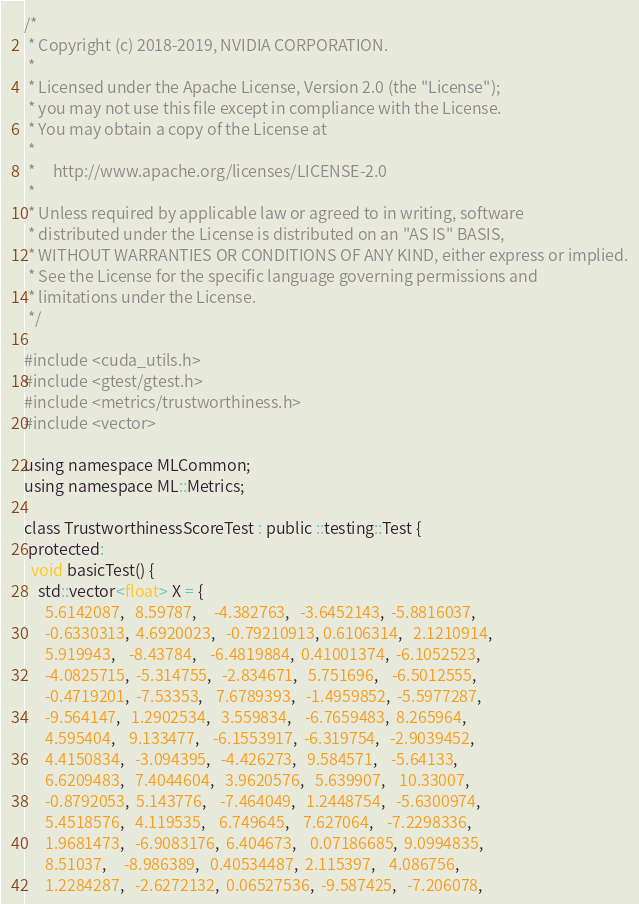<code> <loc_0><loc_0><loc_500><loc_500><_Cuda_>/*
 * Copyright (c) 2018-2019, NVIDIA CORPORATION.
 *
 * Licensed under the Apache License, Version 2.0 (the "License");
 * you may not use this file except in compliance with the License.
 * You may obtain a copy of the License at
 *
 *     http://www.apache.org/licenses/LICENSE-2.0
 *
 * Unless required by applicable law or agreed to in writing, software
 * distributed under the License is distributed on an "AS IS" BASIS,
 * WITHOUT WARRANTIES OR CONDITIONS OF ANY KIND, either express or implied.
 * See the License for the specific language governing permissions and
 * limitations under the License.
 */

#include <cuda_utils.h>
#include <gtest/gtest.h>
#include <metrics/trustworthiness.h>
#include <vector>

using namespace MLCommon;
using namespace ML::Metrics;

class TrustworthinessScoreTest : public ::testing::Test {
 protected:
  void basicTest() {
    std::vector<float> X = {
      5.6142087,   8.59787,     -4.382763,   -3.6452143,  -5.8816037,
      -0.6330313,  4.6920023,   -0.79210913, 0.6106314,   2.1210914,
      5.919943,    -8.43784,    -6.4819884,  0.41001374,  -6.1052523,
      -4.0825715,  -5.314755,   -2.834671,   5.751696,    -6.5012555,
      -0.4719201,  -7.53353,    7.6789393,   -1.4959852,  -5.5977287,
      -9.564147,   1.2902534,   3.559834,    -6.7659483,  8.265964,
      4.595404,    9.133477,    -6.1553917,  -6.319754,   -2.9039452,
      4.4150834,   -3.094395,   -4.426273,   9.584571,    -5.64133,
      6.6209483,   7.4044604,   3.9620576,   5.639907,    10.33007,
      -0.8792053,  5.143776,    -7.464049,   1.2448754,   -5.6300974,
      5.4518576,   4.119535,    6.749645,    7.627064,    -7.2298336,
      1.9681473,   -6.9083176,  6.404673,    0.07186685,  9.0994835,
      8.51037,     -8.986389,   0.40534487,  2.115397,    4.086756,
      1.2284287,   -2.6272132,  0.06527536,  -9.587425,   -7.206078,</code> 